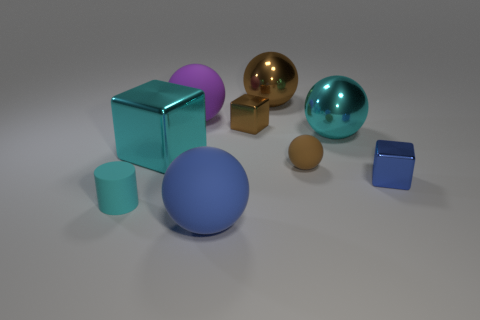The block that is the same size as the cyan ball is what color? cyan 